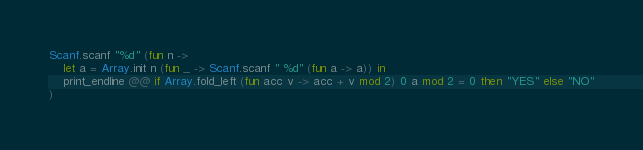<code> <loc_0><loc_0><loc_500><loc_500><_OCaml_>Scanf.scanf "%d" (fun n ->
    let a = Array.init n (fun _ -> Scanf.scanf " %d" (fun a -> a)) in
    print_endline @@ if Array.fold_left (fun acc v -> acc + v mod 2) 0 a mod 2 = 0 then "YES" else "NO"
)</code> 